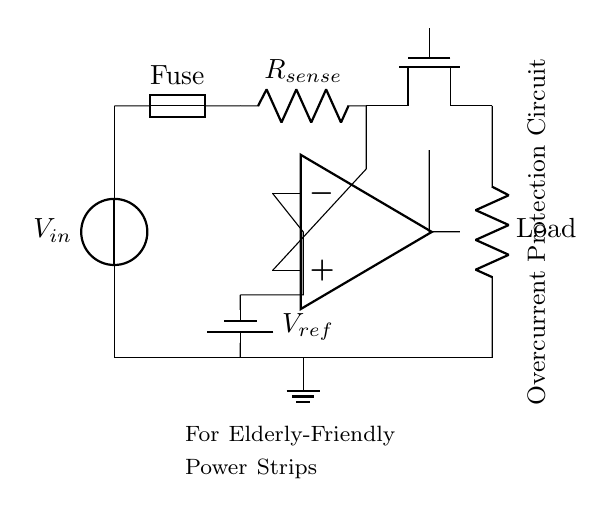What is the function of the fuse? The fuse protects the circuit by breaking the connection when the current exceeds a certain threshold, preventing damage to other components.
Answer: Protection What is the component used for current sensing? The current sensing resistor, labeled as R_sense in the circuit, provides a measurable voltage drop proportional to the current flow, which is monitored for overcurrent conditions.
Answer: R_sense What is the reference voltage source? The reference voltage source is denoted as V_ref, which sets the threshold for the comparator to determine if the current is excessive.
Answer: V_ref How many main active components are in the circuit? The circuit contains four main active components: the fuse, the current sensing resistor, the MOSFET, and the operational amplifier (op amp).
Answer: Four What happens when the sensed current exceeds the threshold? When the sensed current surpasses the threshold set by V_ref, the operational amplifier outputs a signal that turns off the MOSFET, disconnecting the load to prevent further current flow.
Answer: The MOSFET turns off Which component is controlling the load? The component controlling the load is the MOSFET; it acts as a switch, regulating current flow based on the feedback from the operational amplifier.
Answer: MOSFET What is the purpose of the operational amplifier in this circuit? The operational amplifier compares the voltage across the current sensing resistor with the reference voltage to detect overcurrent conditions, providing a control signal to the MOSFET.
Answer: Overcurrent detection 